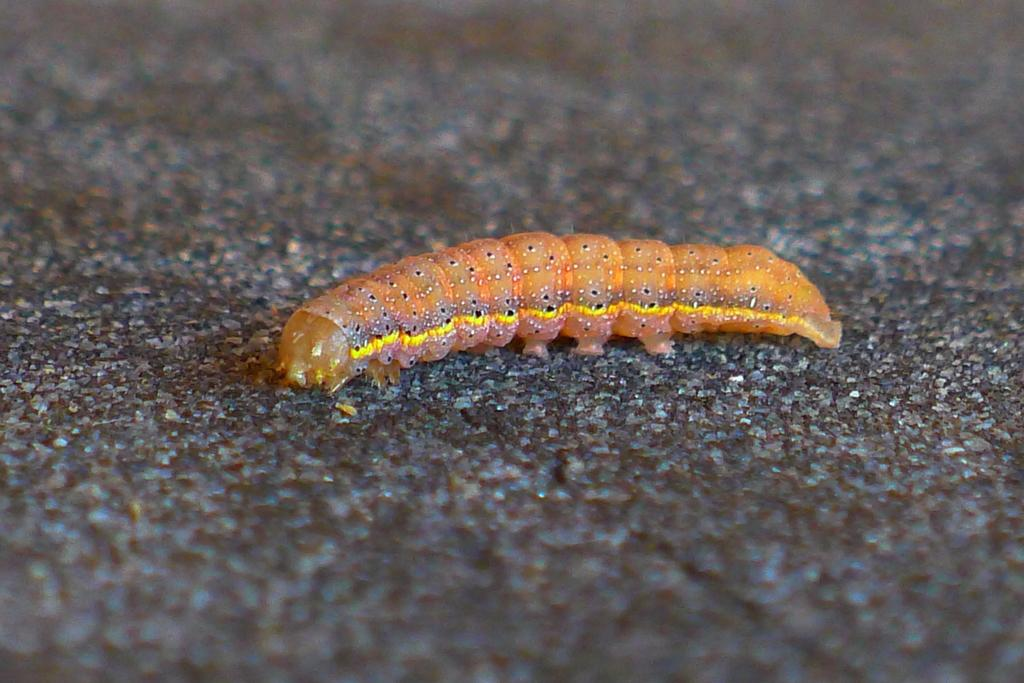What type of creature is present in the image? There is an insect in the image. Can you describe the insect's location in the image? The insect is on the ground in the image. What type of office furniture can be seen in the image? There is no office furniture present in the image; it features an insect on the ground. What type of stitch is being used by the insect in the image? Insects do not use stitches, so this question is not applicable to the image. 